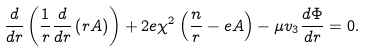Convert formula to latex. <formula><loc_0><loc_0><loc_500><loc_500>\frac { d } { d r } \left ( \frac { 1 } { r } \frac { d } { d r } \left ( r A \right ) \right ) + 2 e \chi ^ { 2 } \left ( \frac { n } { r } - e A \right ) - \mu v _ { 3 } \frac { d \Phi } { d r } = 0 .</formula> 